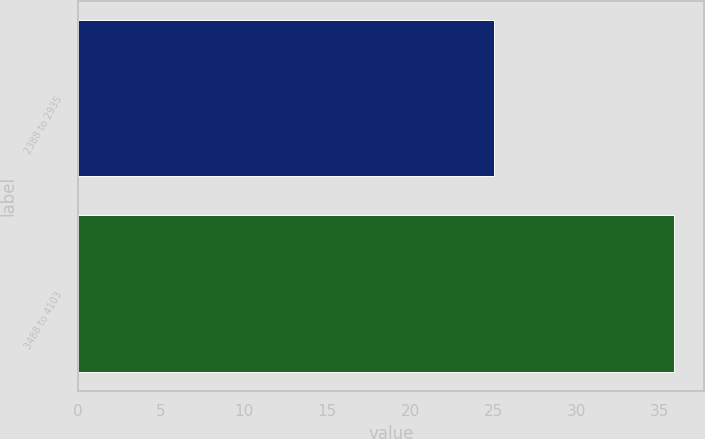Convert chart to OTSL. <chart><loc_0><loc_0><loc_500><loc_500><bar_chart><fcel>2388 to 2935<fcel>3488 to 4103<nl><fcel>25.06<fcel>35.88<nl></chart> 